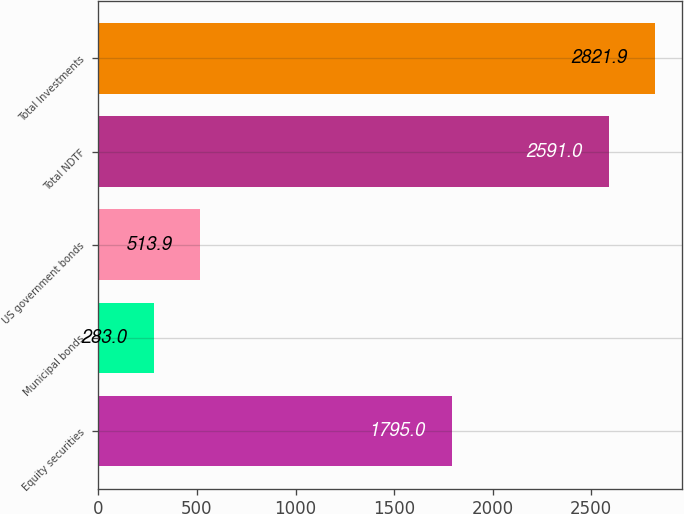Convert chart. <chart><loc_0><loc_0><loc_500><loc_500><bar_chart><fcel>Equity securities<fcel>Municipal bonds<fcel>US government bonds<fcel>Total NDTF<fcel>Total Investments<nl><fcel>1795<fcel>283<fcel>513.9<fcel>2591<fcel>2821.9<nl></chart> 